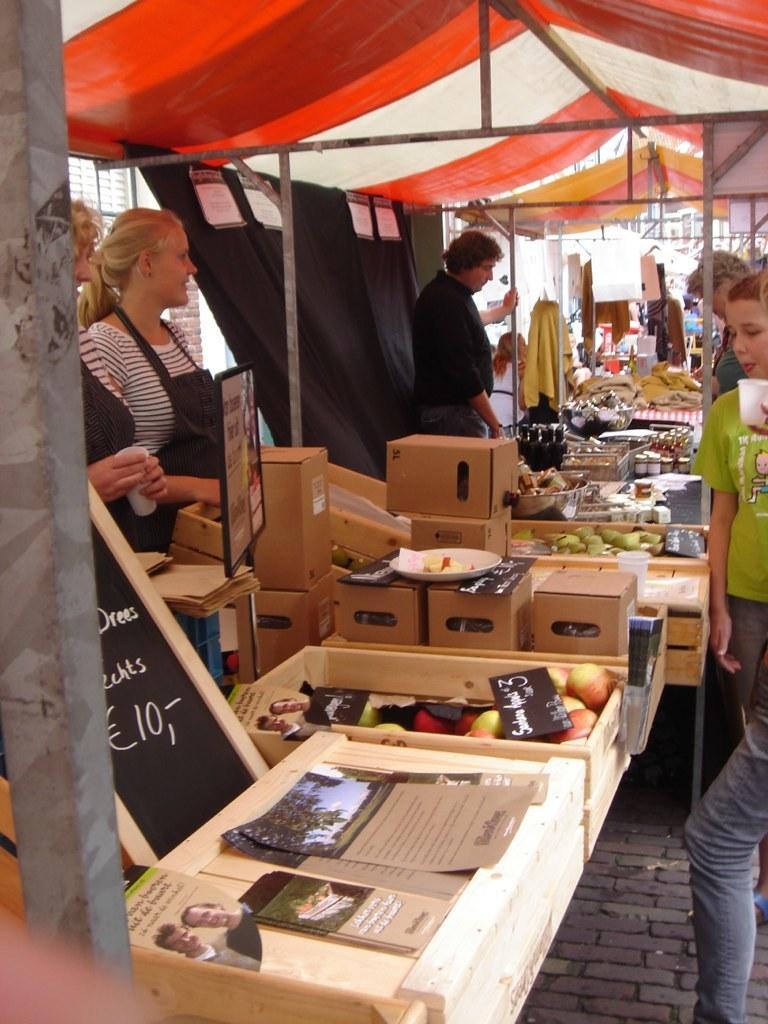Can you describe this image briefly? In this image we can see a few stalls with posters, food items and few objects and people near the stalls and there is a black color curtain with posters. 